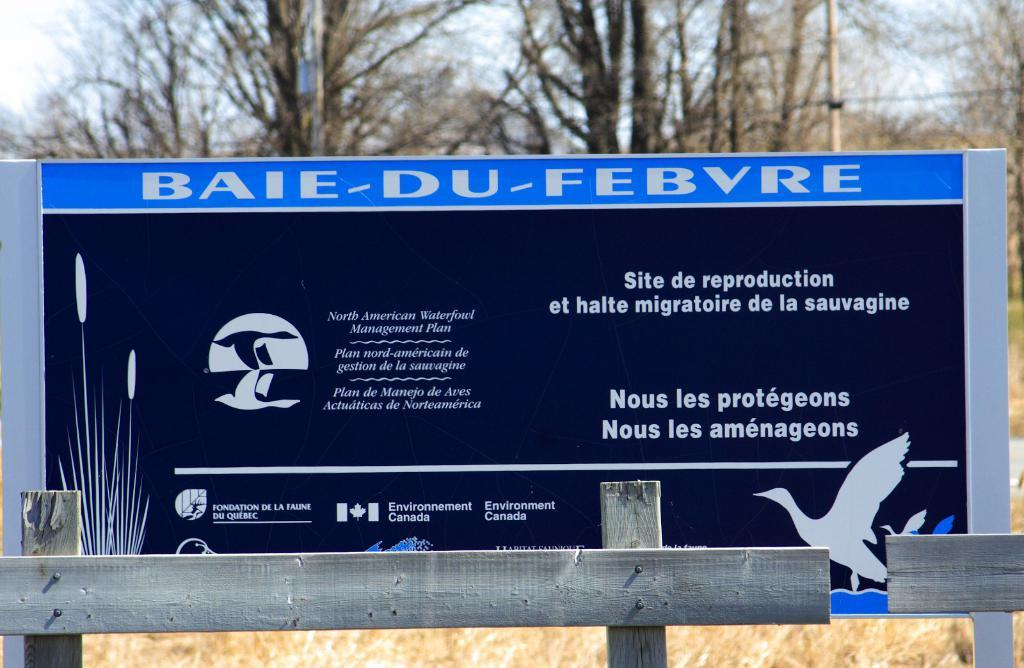<image>
Summarize the visual content of the image. Baie Du Febvre banner with Environment Canada sign  for North Amercian Waterfowl Management Plan. 